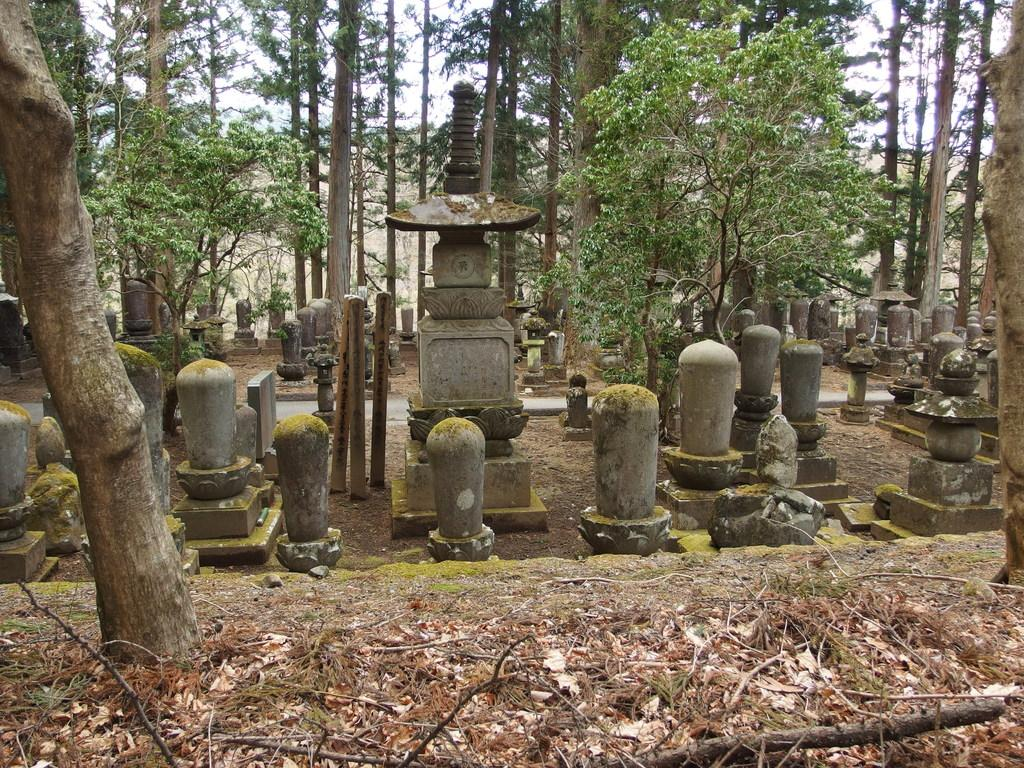What type of artwork is present in the image? There are sculptures in the image. What other natural elements can be seen in the image? There are trees in the image. What is visible in the background of the image? The sky is visible in the background of the image. How many cents are depicted on the sculptures in the image? There are no cents depicted on the sculptures in the image. What type of pie is being served in the image? There is no pie present in the image. 